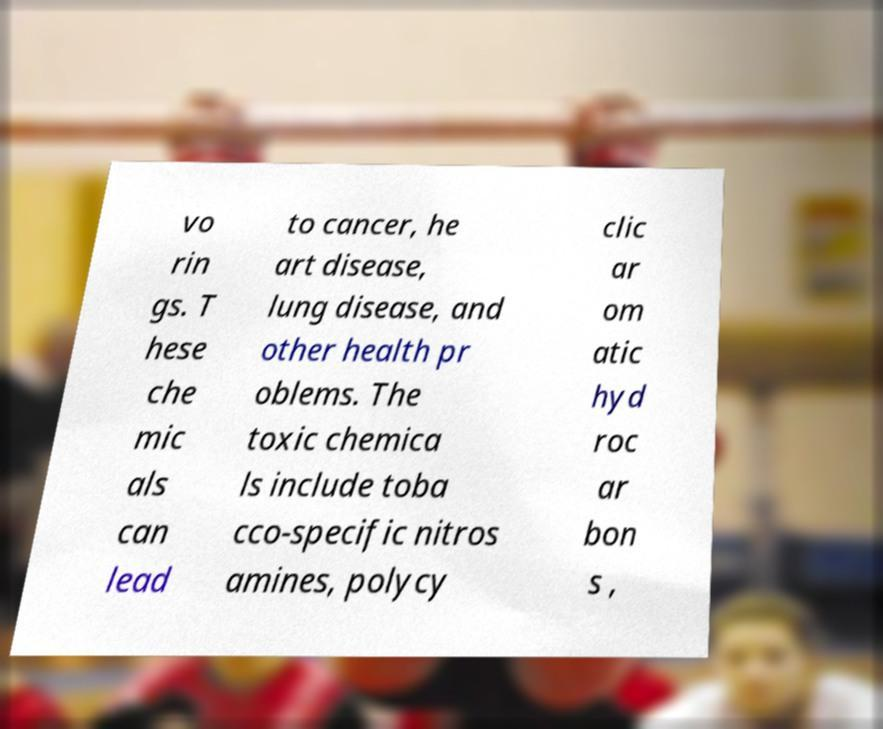Please read and relay the text visible in this image. What does it say? vo rin gs. T hese che mic als can lead to cancer, he art disease, lung disease, and other health pr oblems. The toxic chemica ls include toba cco-specific nitros amines, polycy clic ar om atic hyd roc ar bon s , 